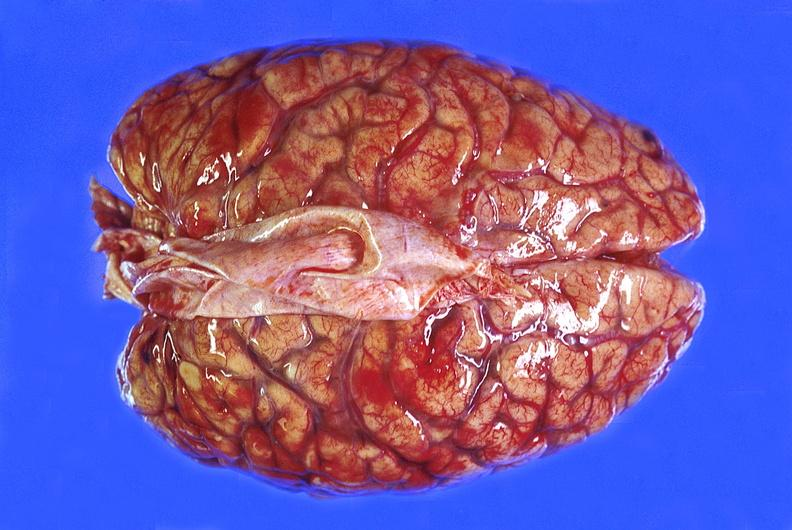does hydrocele show brain abscess?
Answer the question using a single word or phrase. No 